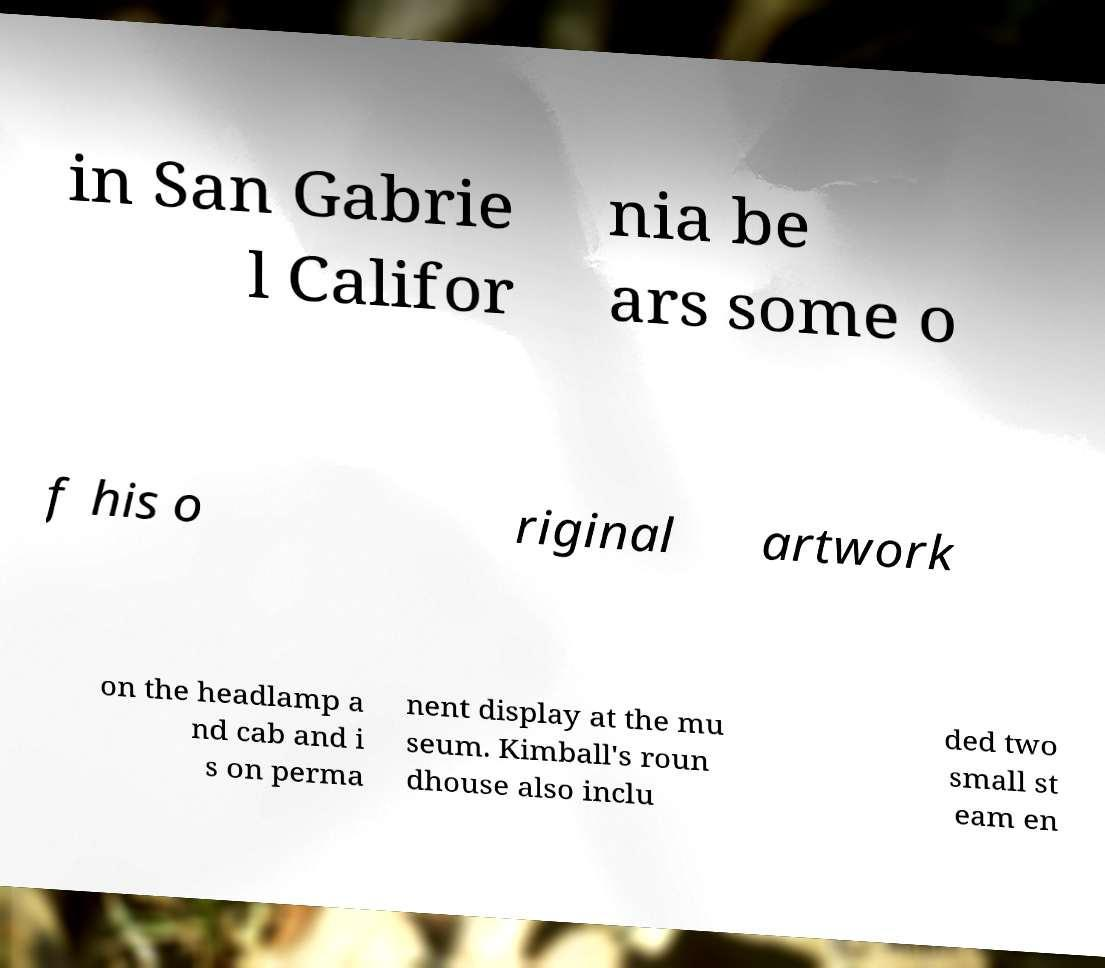Could you assist in decoding the text presented in this image and type it out clearly? in San Gabrie l Califor nia be ars some o f his o riginal artwork on the headlamp a nd cab and i s on perma nent display at the mu seum. Kimball's roun dhouse also inclu ded two small st eam en 